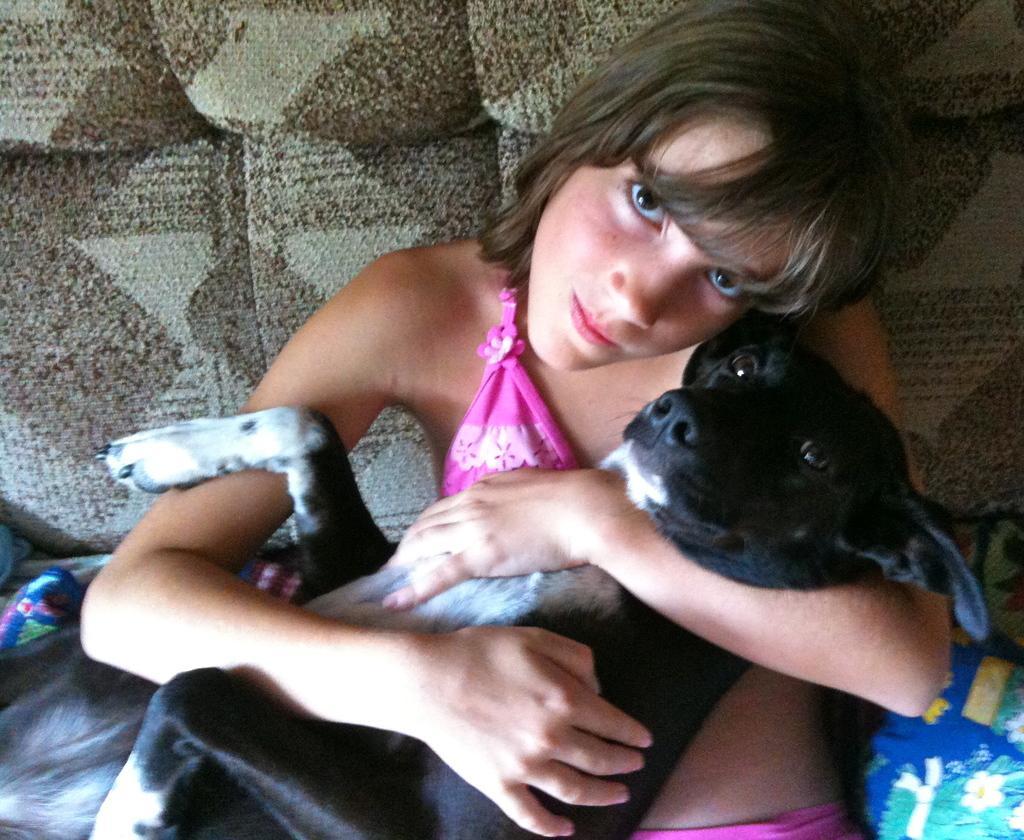Please provide a concise description of this image. In this picture we can see a lady holding a black dog. 